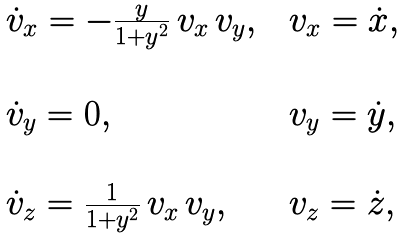<formula> <loc_0><loc_0><loc_500><loc_500>\begin{array} { l c l } \dot { v } _ { x } = - \frac { y } { 1 + y ^ { 2 } } \, v _ { x } \, v _ { y } , & & v _ { x } = \dot { x } , \\ \\ \dot { v } _ { y } = 0 , & & v _ { y } = \dot { y } , \\ \\ \dot { v } _ { z } = \frac { 1 } { 1 + y ^ { 2 } } \, v _ { x } \, v _ { y } , & & v _ { z } = \dot { z } , \\ \\ \end{array}</formula> 